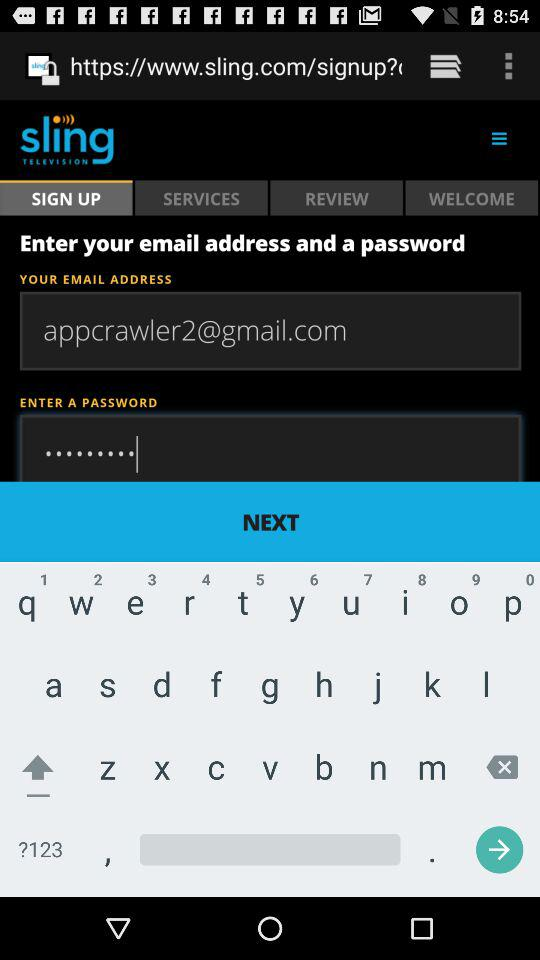Which option is selected for "Sling"? The selected option is "SIGN UP". 